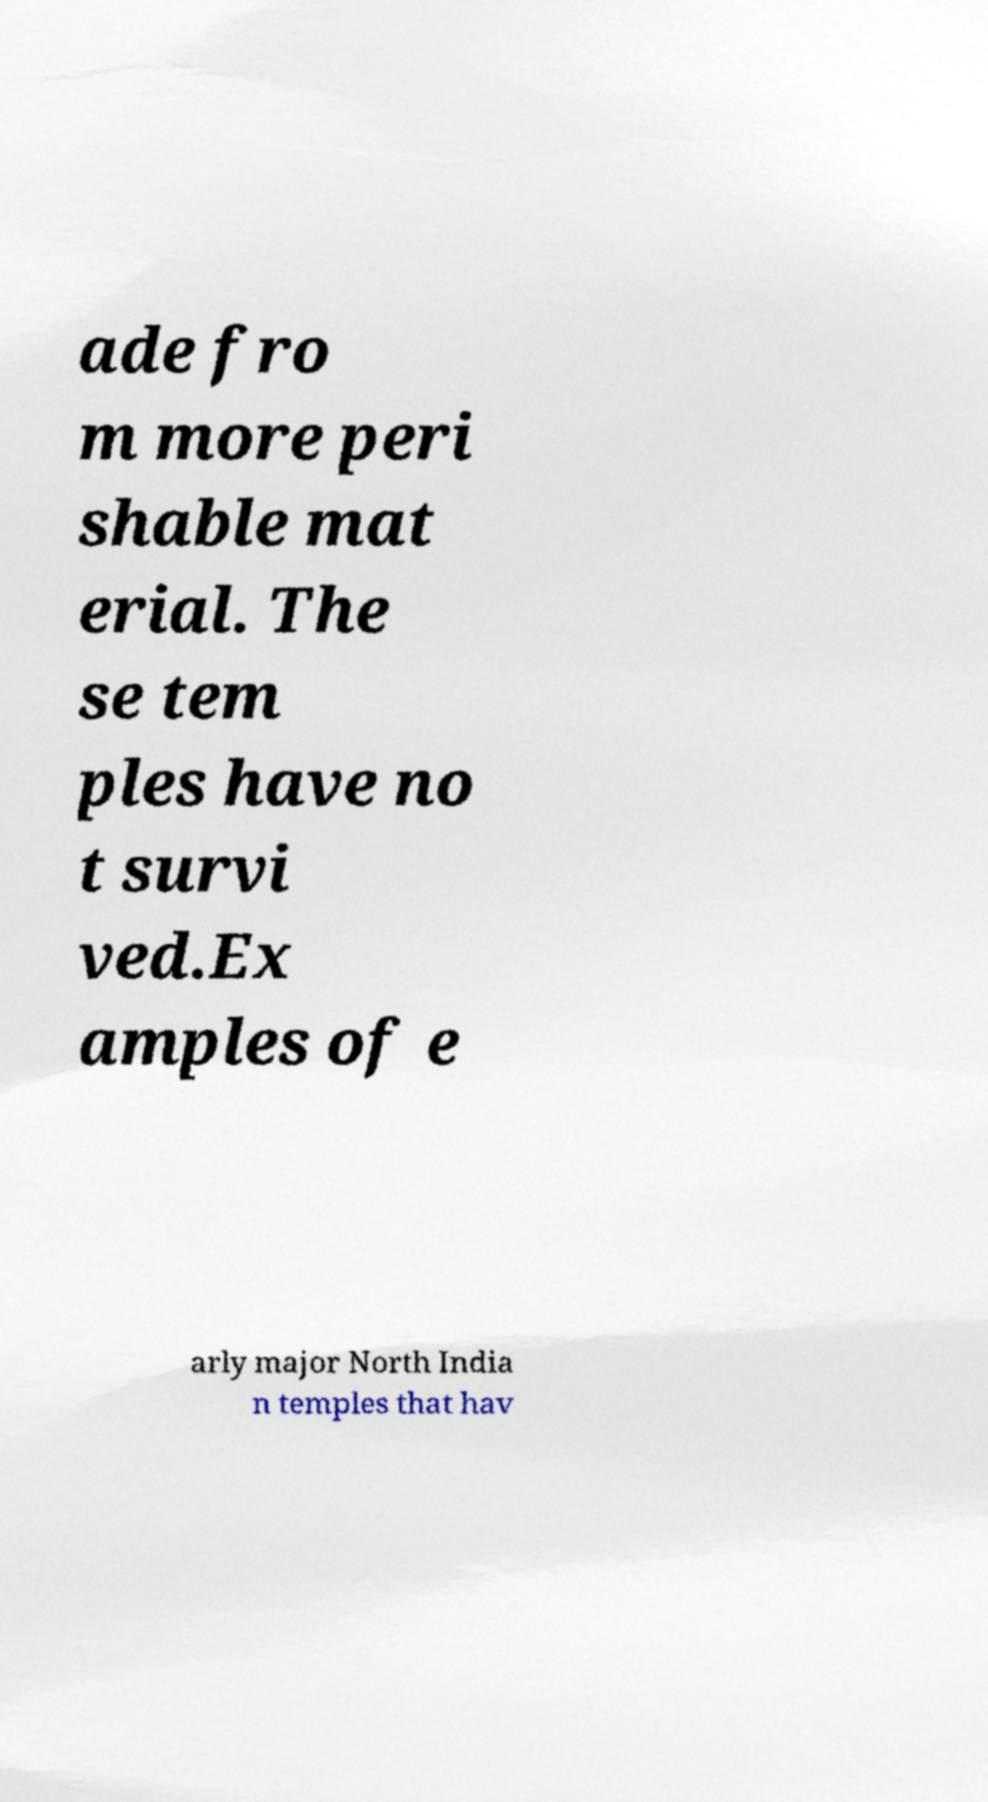Could you extract and type out the text from this image? ade fro m more peri shable mat erial. The se tem ples have no t survi ved.Ex amples of e arly major North India n temples that hav 